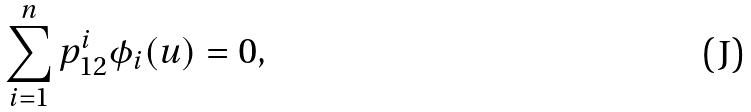Convert formula to latex. <formula><loc_0><loc_0><loc_500><loc_500>\sum _ { i = 1 } ^ { n } p _ { 1 2 } ^ { i } \phi _ { i } ( u ) = 0 ,</formula> 